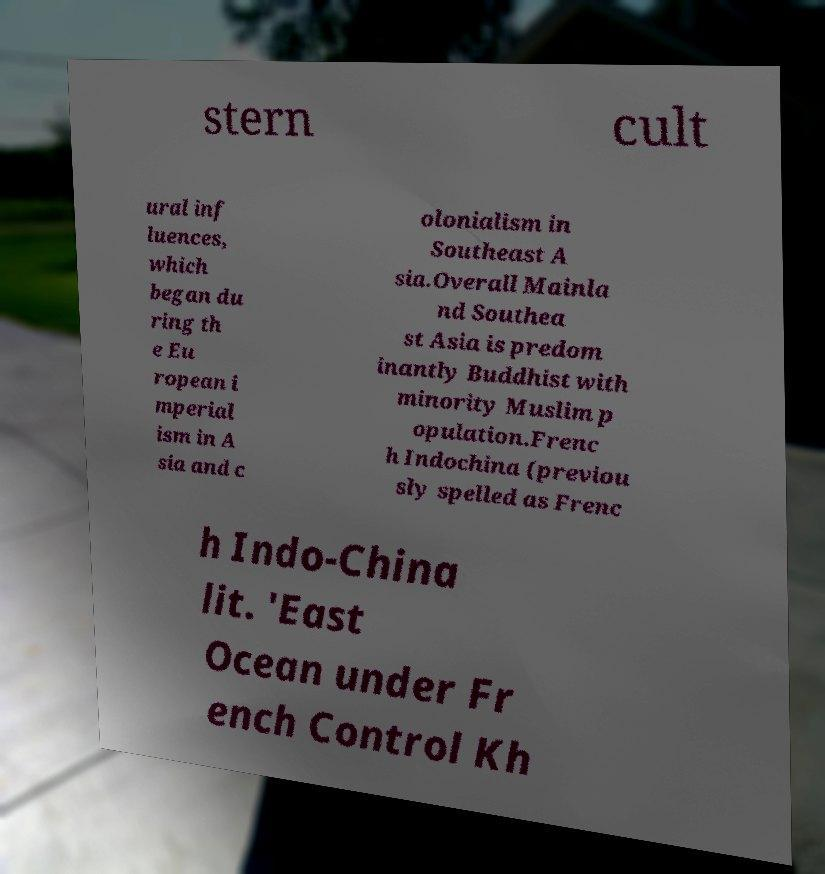Please read and relay the text visible in this image. What does it say? stern cult ural inf luences, which began du ring th e Eu ropean i mperial ism in A sia and c olonialism in Southeast A sia.Overall Mainla nd Southea st Asia is predom inantly Buddhist with minority Muslim p opulation.Frenc h Indochina (previou sly spelled as Frenc h Indo-China lit. 'East Ocean under Fr ench Control Kh 